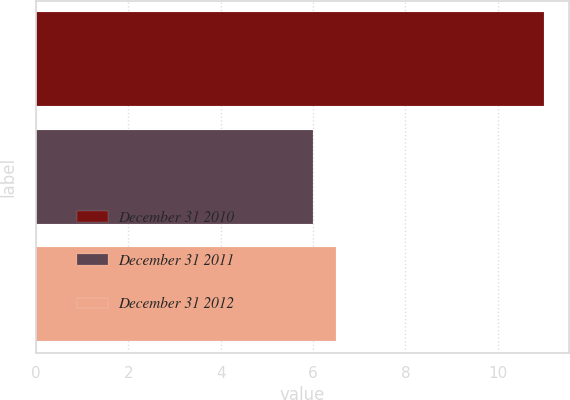Convert chart to OTSL. <chart><loc_0><loc_0><loc_500><loc_500><bar_chart><fcel>December 31 2010<fcel>December 31 2011<fcel>December 31 2012<nl><fcel>11<fcel>6<fcel>6.5<nl></chart> 